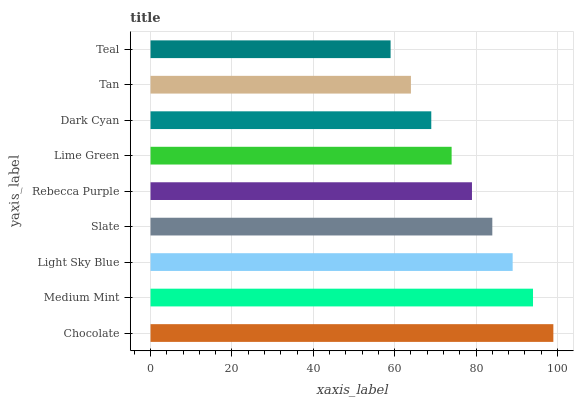Is Teal the minimum?
Answer yes or no. Yes. Is Chocolate the maximum?
Answer yes or no. Yes. Is Medium Mint the minimum?
Answer yes or no. No. Is Medium Mint the maximum?
Answer yes or no. No. Is Chocolate greater than Medium Mint?
Answer yes or no. Yes. Is Medium Mint less than Chocolate?
Answer yes or no. Yes. Is Medium Mint greater than Chocolate?
Answer yes or no. No. Is Chocolate less than Medium Mint?
Answer yes or no. No. Is Rebecca Purple the high median?
Answer yes or no. Yes. Is Rebecca Purple the low median?
Answer yes or no. Yes. Is Light Sky Blue the high median?
Answer yes or no. No. Is Medium Mint the low median?
Answer yes or no. No. 